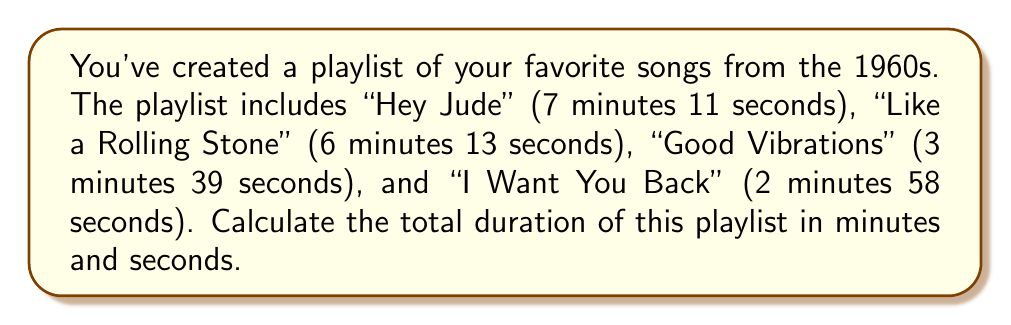Could you help me with this problem? Let's approach this step-by-step:

1) First, let's convert all times to seconds:
   - "Hey Jude": $7 \times 60 + 11 = 431$ seconds
   - "Like a Rolling Stone": $6 \times 60 + 13 = 373$ seconds
   - "Good Vibrations": $3 \times 60 + 39 = 219$ seconds
   - "I Want You Back": $2 \times 60 + 58 = 178$ seconds

2) Now, let's add all these seconds:
   $431 + 373 + 219 + 178 = 1201$ seconds

3) To convert this back to minutes and seconds:
   - Divide by 60 to get minutes: $1201 \div 60 = 20$ remainder $1$
   - The remainder is the number of seconds

Therefore, the total duration is 20 minutes and 1 second.
Answer: 20 minutes 1 second 